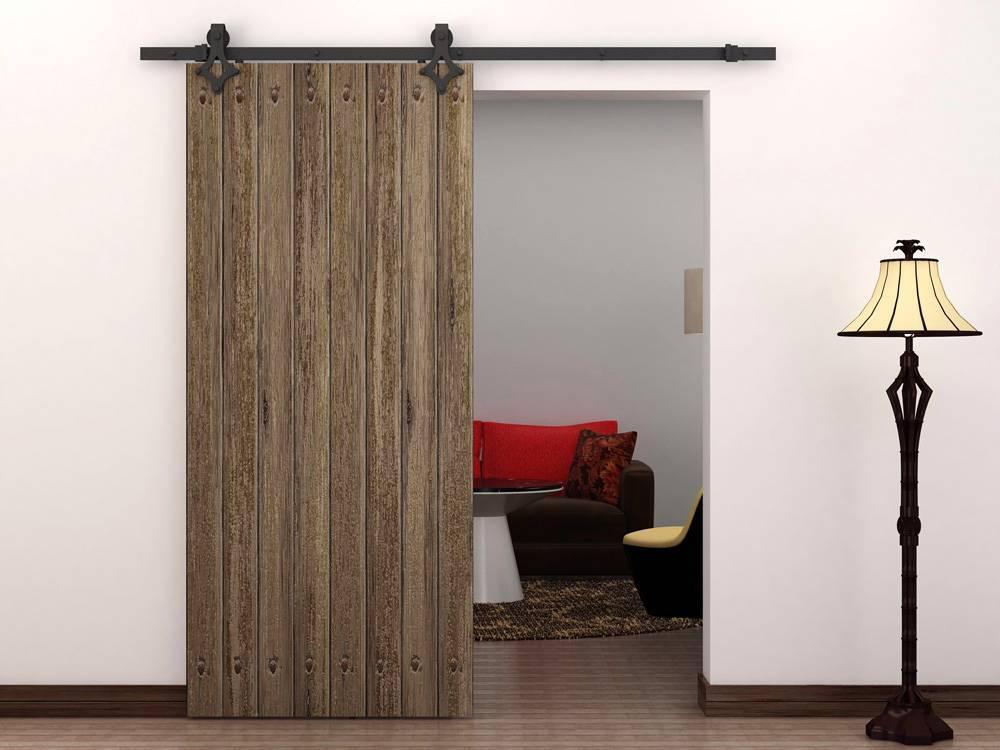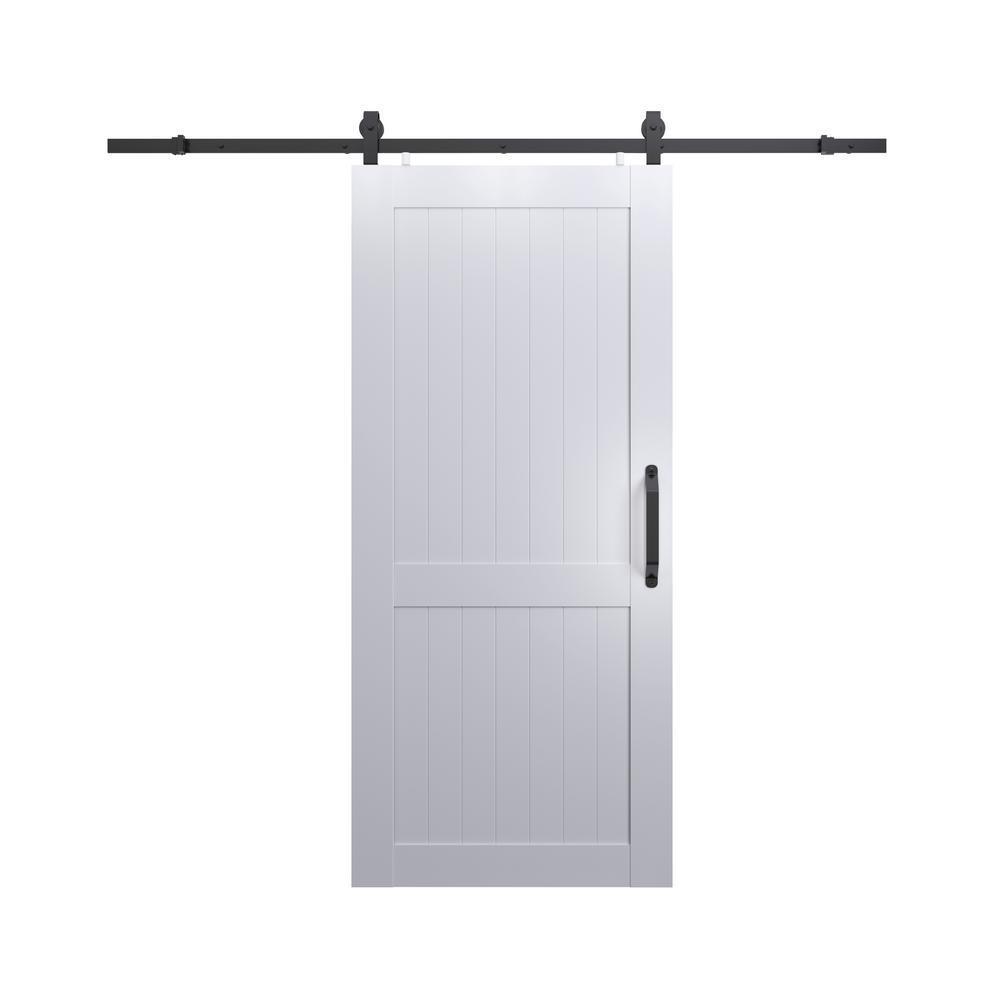The first image is the image on the left, the second image is the image on the right. Considering the images on both sides, is "The right image shows a sliding door to the left of the dooorway." valid? Answer yes or no. No. The first image is the image on the left, the second image is the image on the right. Assess this claim about the two images: "The left and right image contains the same number of hanging doors made of solid wood.". Correct or not? Answer yes or no. Yes. 